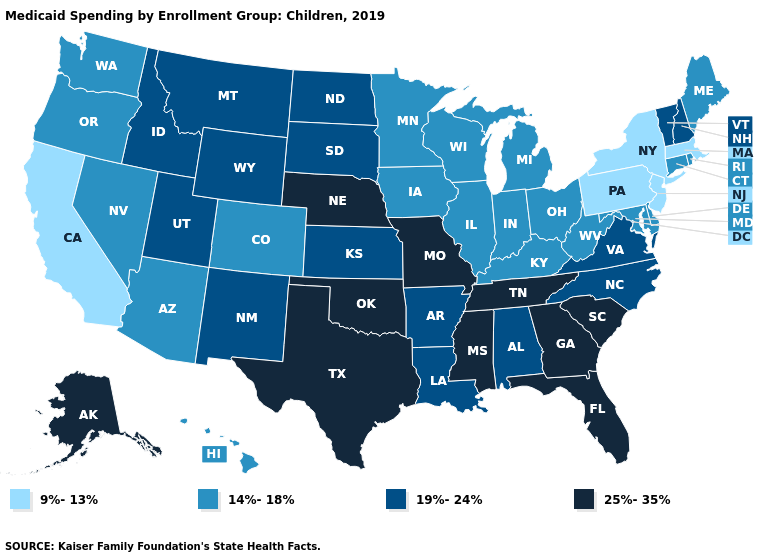What is the lowest value in states that border Rhode Island?
Short answer required. 9%-13%. Is the legend a continuous bar?
Write a very short answer. No. Name the states that have a value in the range 19%-24%?
Give a very brief answer. Alabama, Arkansas, Idaho, Kansas, Louisiana, Montana, New Hampshire, New Mexico, North Carolina, North Dakota, South Dakota, Utah, Vermont, Virginia, Wyoming. Name the states that have a value in the range 14%-18%?
Concise answer only. Arizona, Colorado, Connecticut, Delaware, Hawaii, Illinois, Indiana, Iowa, Kentucky, Maine, Maryland, Michigan, Minnesota, Nevada, Ohio, Oregon, Rhode Island, Washington, West Virginia, Wisconsin. Among the states that border Indiana , which have the highest value?
Give a very brief answer. Illinois, Kentucky, Michigan, Ohio. Does New York have the lowest value in the USA?
Quick response, please. Yes. Among the states that border North Dakota , does South Dakota have the lowest value?
Give a very brief answer. No. Name the states that have a value in the range 19%-24%?
Write a very short answer. Alabama, Arkansas, Idaho, Kansas, Louisiana, Montana, New Hampshire, New Mexico, North Carolina, North Dakota, South Dakota, Utah, Vermont, Virginia, Wyoming. What is the highest value in the West ?
Quick response, please. 25%-35%. Name the states that have a value in the range 9%-13%?
Be succinct. California, Massachusetts, New Jersey, New York, Pennsylvania. What is the value of Wisconsin?
Short answer required. 14%-18%. What is the value of Utah?
Short answer required. 19%-24%. How many symbols are there in the legend?
Keep it brief. 4. Among the states that border Delaware , does Pennsylvania have the lowest value?
Quick response, please. Yes. What is the lowest value in the MidWest?
Write a very short answer. 14%-18%. 